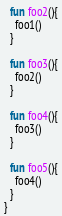<code> <loc_0><loc_0><loc_500><loc_500><_Kotlin_>  fun foo2(){
    foo1()
  }

  fun foo3(){
    foo2()
  }

  fun foo4(){
    foo3()
  }

  fun foo5(){
    foo4()
  }
}</code> 